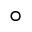<formula> <loc_0><loc_0><loc_500><loc_500>^ { \circ }</formula> 